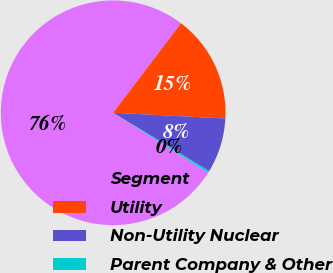<chart> <loc_0><loc_0><loc_500><loc_500><pie_chart><fcel>Segment<fcel>Utility<fcel>Non-Utility Nuclear<fcel>Parent Company & Other<nl><fcel>76.37%<fcel>15.49%<fcel>7.88%<fcel>0.27%<nl></chart> 